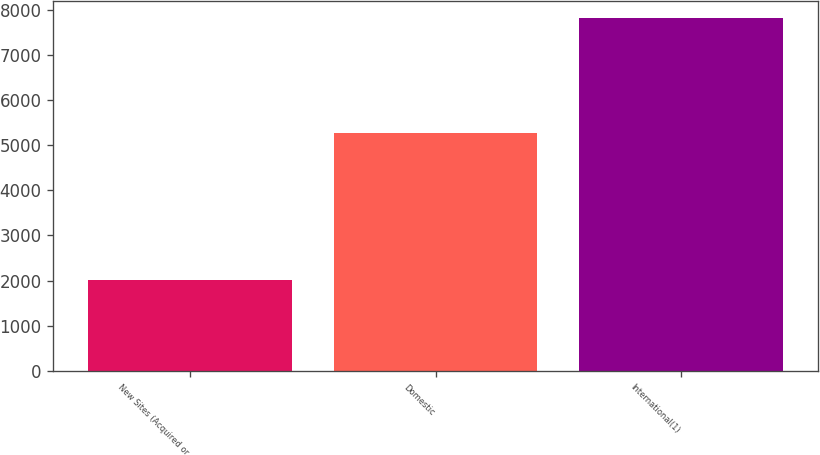Convert chart. <chart><loc_0><loc_0><loc_500><loc_500><bar_chart><fcel>New Sites (Acquired or<fcel>Domestic<fcel>International(1)<nl><fcel>2013<fcel>5260<fcel>7810<nl></chart> 